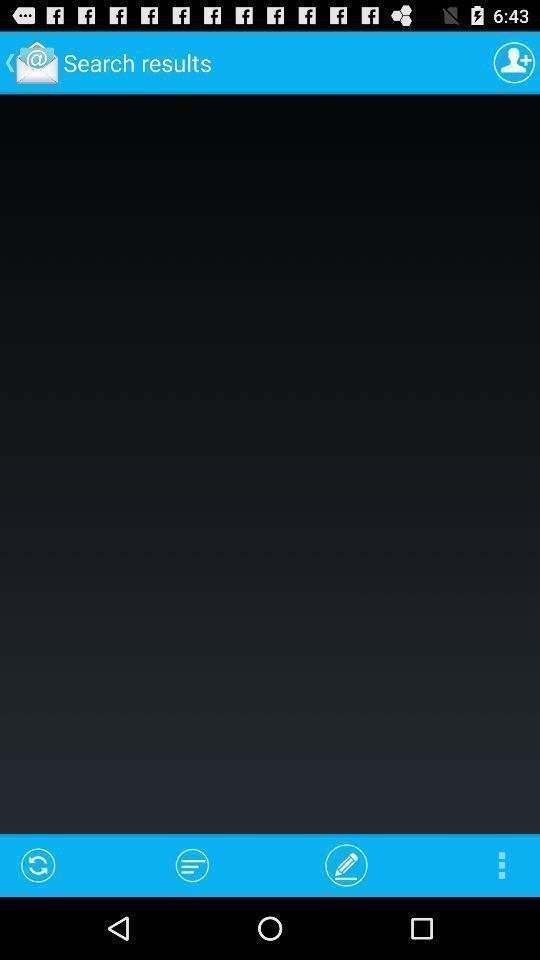Summarize the main components in this picture. Screen showing the blank page for search result. 